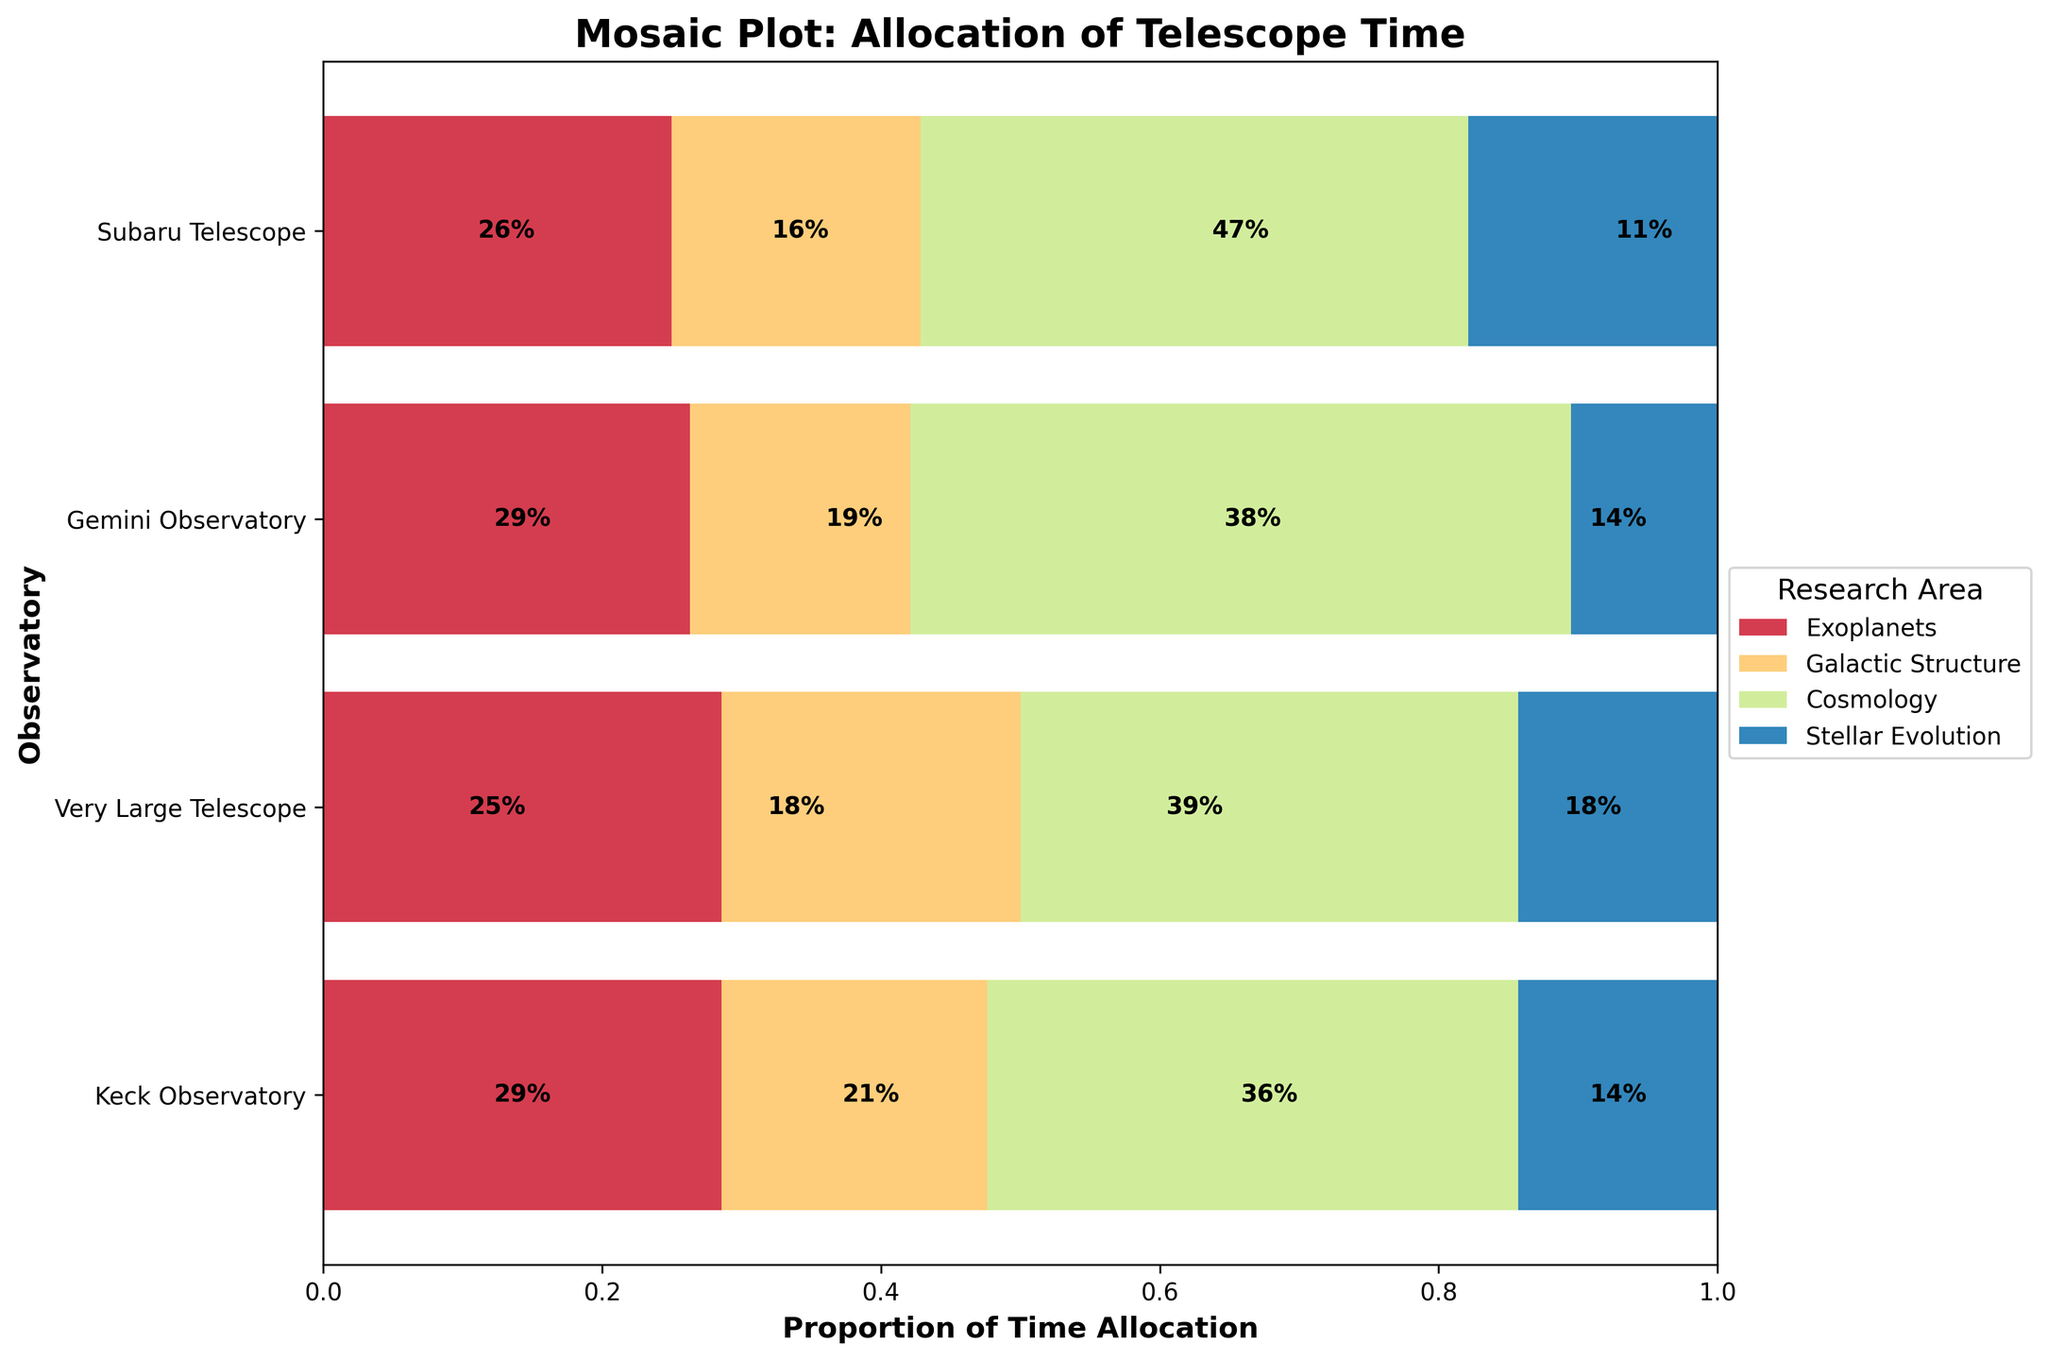What is the title of the mosaic plot? The title of the plot is usually displayed at the top and provides an overview of the visualized data. Here, the title is "Mosaic Plot: Allocation of Telescope Time".
Answer: Mosaic Plot: Allocation of Telescope Time Which observatory allocates the most time to Cosmology? By observing the horizontal segments corresponding to each observatory, we see which one has the largest segment for Cosmology. The segment for Very Large Telescope appears the largest.
Answer: Very Large Telescope What proportion of Keck Observatory's time is dedicated to Galactic Structure? We look at the bar representing Keck Observatory and the segment labeled for Galactic Structure. The percentage label inside the segment shows 23%.
Answer: 23% Which research area receives the least time allocation at Subaru Telescope? By comparing the segments for each research area within the Subaru Telescope bar, we find the smallest segment. Stellar Evolution has the smallest segment.
Answer: Stellar Evolution How does the time allocation for Exoplanets compare between Keck Observatory and Very Large Telescope? We compare the size of the Exoplanets segments for both observatories. Keck Observatory's segment is slightly larger than that of Very Large Telescope.
Answer: Keck Observatory allocates more time What is the color representing Stellar Evolution? We identify the color by looking at the legend and locating the label for Stellar Evolution. The color appears green in this context.
Answer: Green What is the total proportion of time allocated to research areas other than Cosmology at Gemini Observatory? We subtract the proportion of time allocated to Cosmology from 100% by summing the proportions of other segments. Cosmology is 40%, thus the proportion for other areas is 60%.
Answer: 60% Which observatory has the most balanced time allocation across different research areas? We look at the proportions of the segments for each research area within each bar. Gemini Observatory's segments seem most uniform in size.
Answer: Gemini Observatory How many research areas are represented in the mosaic plot? We count the number of different research areas listed in the legend. There are four areas listed.
Answer: Four Which research area receives the highest proportion of time at Very Large Telescope? By examining the segments within the Very Large Telescope bar, we identify which segment is the largest. Cosmology has the largest segment.
Answer: Cosmology 